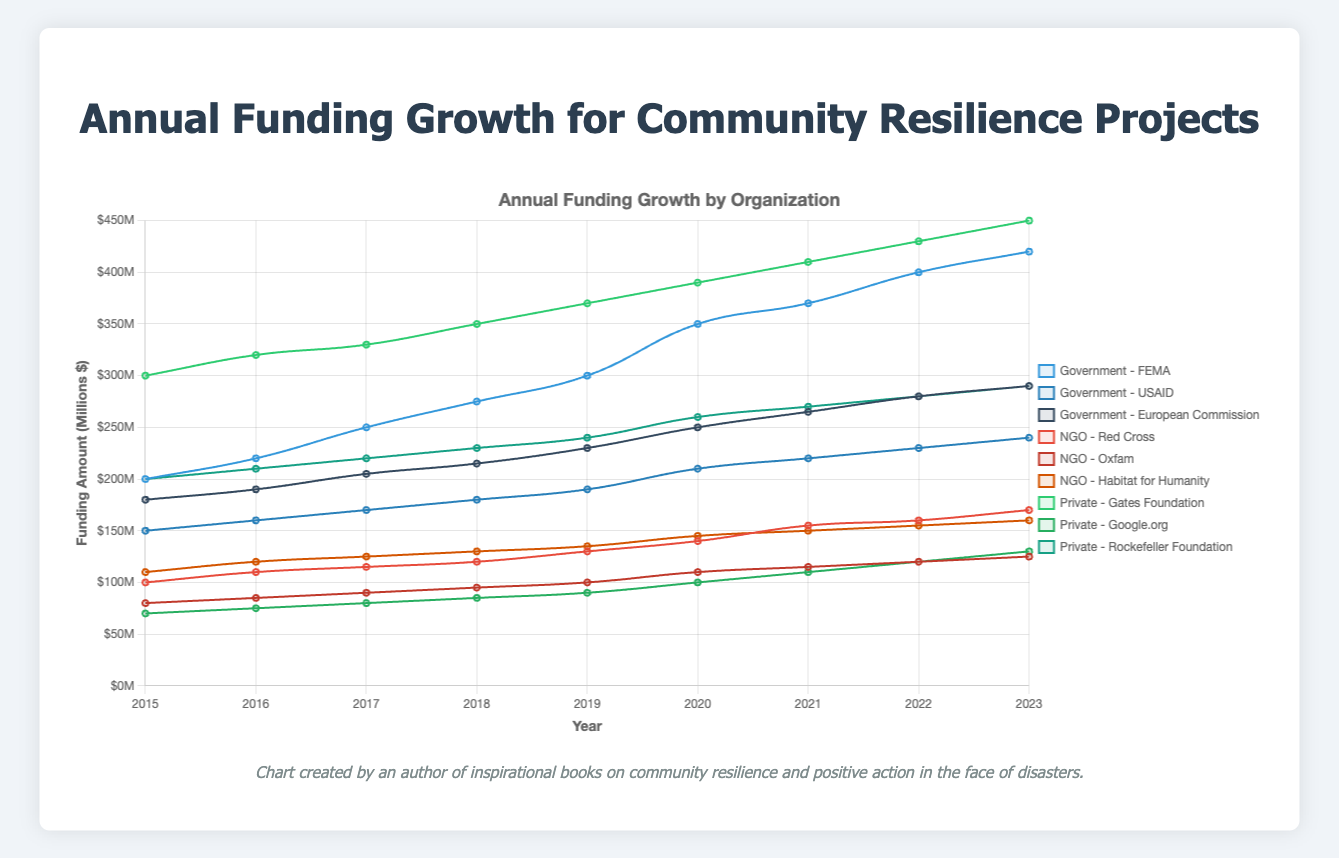Which organization received the highest funding in 2023? To find the organization with the highest funding in 2023, compare the funding amounts for each organization across government, NGO, and private sources for that year. The highest value is $450M by the Gates Foundation.
Answer: Gates Foundation Between FEMA and USAID, which organization's funding showed a higher growth rate from 2015 to 2023? Calculate the growth rates: FEMA: (420-200)/200 = 1.10 (110%), USAID: (240-150)/150 = 0.60 (60%). FEMA displays a higher growth rate.
Answer: FEMA What was the total funding from NGOs in 2022? Sum the funding amounts from Red Cross, Oxfam, and Habitat for Humanity for 2022: 160 + 120 + 155 = 435M.
Answer: $435M How did funding from the European Commission compare to funding from the Rockefeller Foundation in 2019? Compare funding amounts: European Commission in 2019 - $230M; Rockefeller Foundation in 2019 - $240M. The Rockefeller Foundation received slightly more funding than the European Commission in 2019.
Answer: Rockefeller Foundation What was the overall trend in FEMA's funding from 2015 to 2023? Observe the data points for FEMA from 2015 to 2023. The funding consistently increased each year, starting from $200M in 2015 to $420M in 2023.
Answer: Increasing Which organization among Government sources received the least funding in 2020? Compare funding amounts in 2020 for FEMA, USAID, and European Commission: FEMA - $350M, USAID - $210M, European Commission - $250M. USAID received the least funding.
Answer: USAID Between the Red Cross and Google.org, which had a greater increase in funding from 2015 to 2023? Calculate the increase: Red Cross: 170 - 100 = 70M, Google.org: 130 - 70 = 60M. The Red Cross had a greater increase.
Answer: Red Cross Calculate the average annual funding from Oxfam over these years. Add yearly funding from 2015 to 2023 for Oxfam: 80 + 85 + 90 + 95 + 100 + 110 + 115 + 120 + 125 = 920M. Divide by 9 years: 920/9 ≈ 102.22M.
Answer: $102.22M Which private organization showed the most consistent increase in funding? Observe funding trends for Gates Foundation, Google.org, and Rockefeller Foundation from 2015 to 2023. Gates Foundation shows a steady increase from $300M to $450M.
Answer: Gates Foundation 